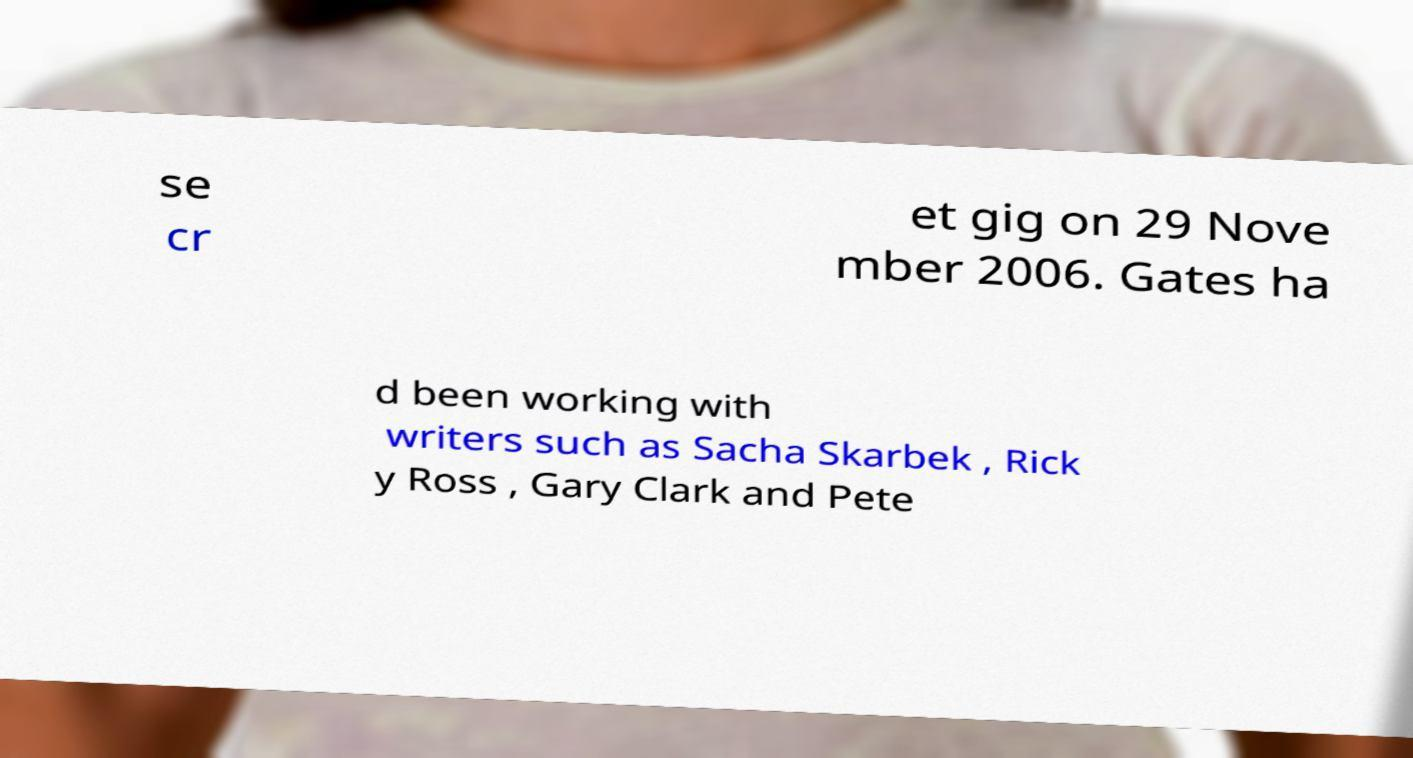There's text embedded in this image that I need extracted. Can you transcribe it verbatim? se cr et gig on 29 Nove mber 2006. Gates ha d been working with writers such as Sacha Skarbek , Rick y Ross , Gary Clark and Pete 